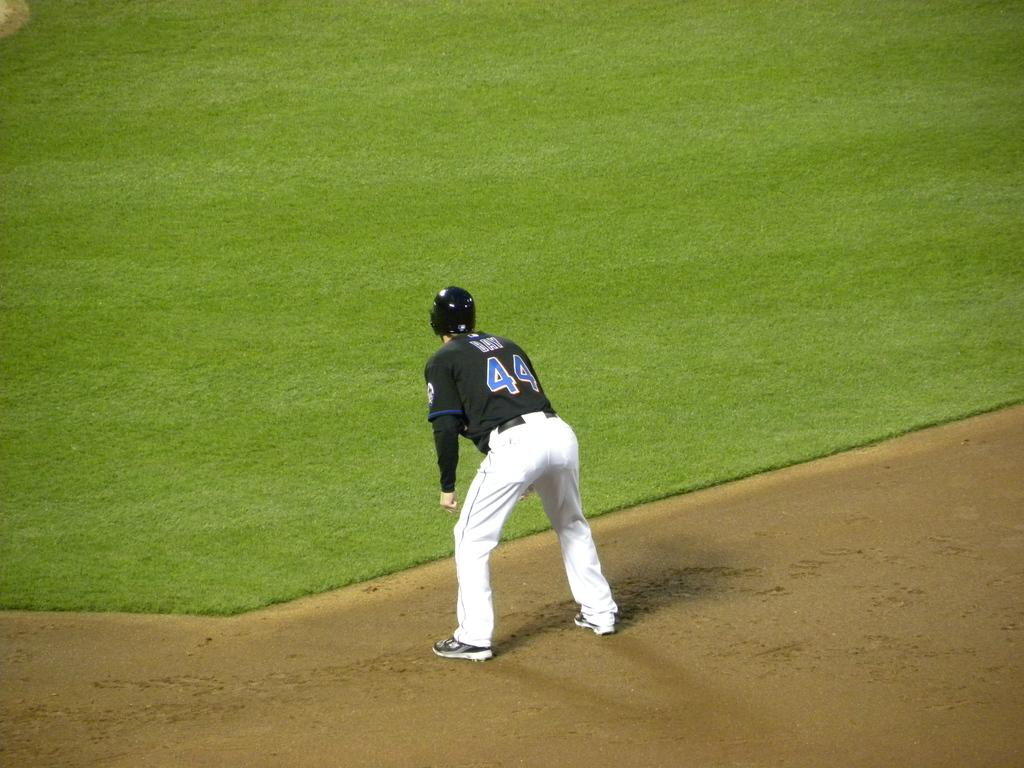Provide a one-sentence caption for the provided image. The baseball player is wearing the jersey number 44. 